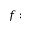<formula> <loc_0><loc_0><loc_500><loc_500>f \colon</formula> 